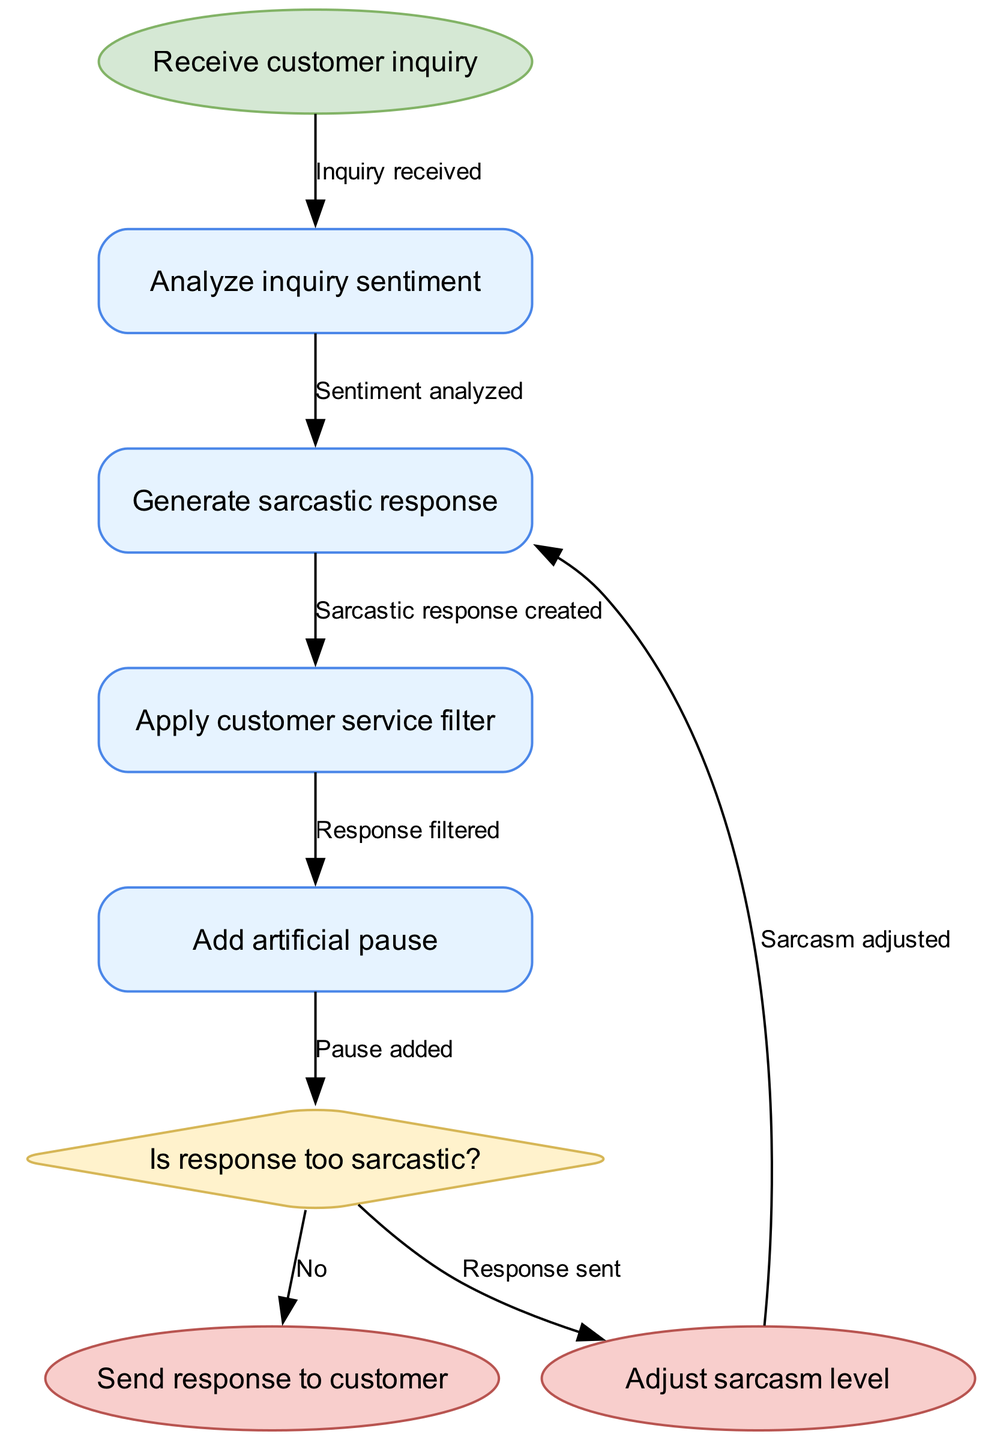What's the starting point of the process? The starting point is labeled as "Receive customer inquiry," which is indicated in the diagram as the first node.
Answer: Receive customer inquiry How many processes are present in the diagram? By counting the individual processes listed in the diagram, there are four labeled processes: "Analyze inquiry sentiment," "Generate sarcastic response," "Apply customer service filter," and "Add artificial pause."
Answer: Four What happens after generating a sarcastic response? After the process "Generate sarcastic response," the next step is "Apply customer service filter," as shown by the connecting edge in the diagram.
Answer: Apply customer service filter What does the decision node assess? The decision node is labeled "Is response too sarcastic?" indicating that it evaluates the sarcasm level of the generated response before determining the next step.
Answer: Is response too sarcastic? If the response is too sarcastic, what happens next? If the response is deemed too sarcastic, the edge labeled "Yes" leads to the end node "Adjust sarcasm level," indicating a need for adjustment before sending it.
Answer: Adjust sarcasm level What is the last process before sending the response to the customer? The last process before sending the response is "Add artificial pause," as this process is positioned just before the decision point that leads to the end nodes.
Answer: Add artificial pause How is the flow affected if the response is not too sarcastic? If the response is not too sarcastic (indicated by the "No" edge), the flow moves directly to "Send response to customer," thus completing the process.
Answer: Send response to customer Which two nodes are oval-shaped in the diagram? The nodes that are oval-shaped are "Receive customer inquiry" at the start and "Send response to customer" at the end, as typically seen for start/end points in flow diagrams.
Answer: Receive customer inquiry, Send response to customer 